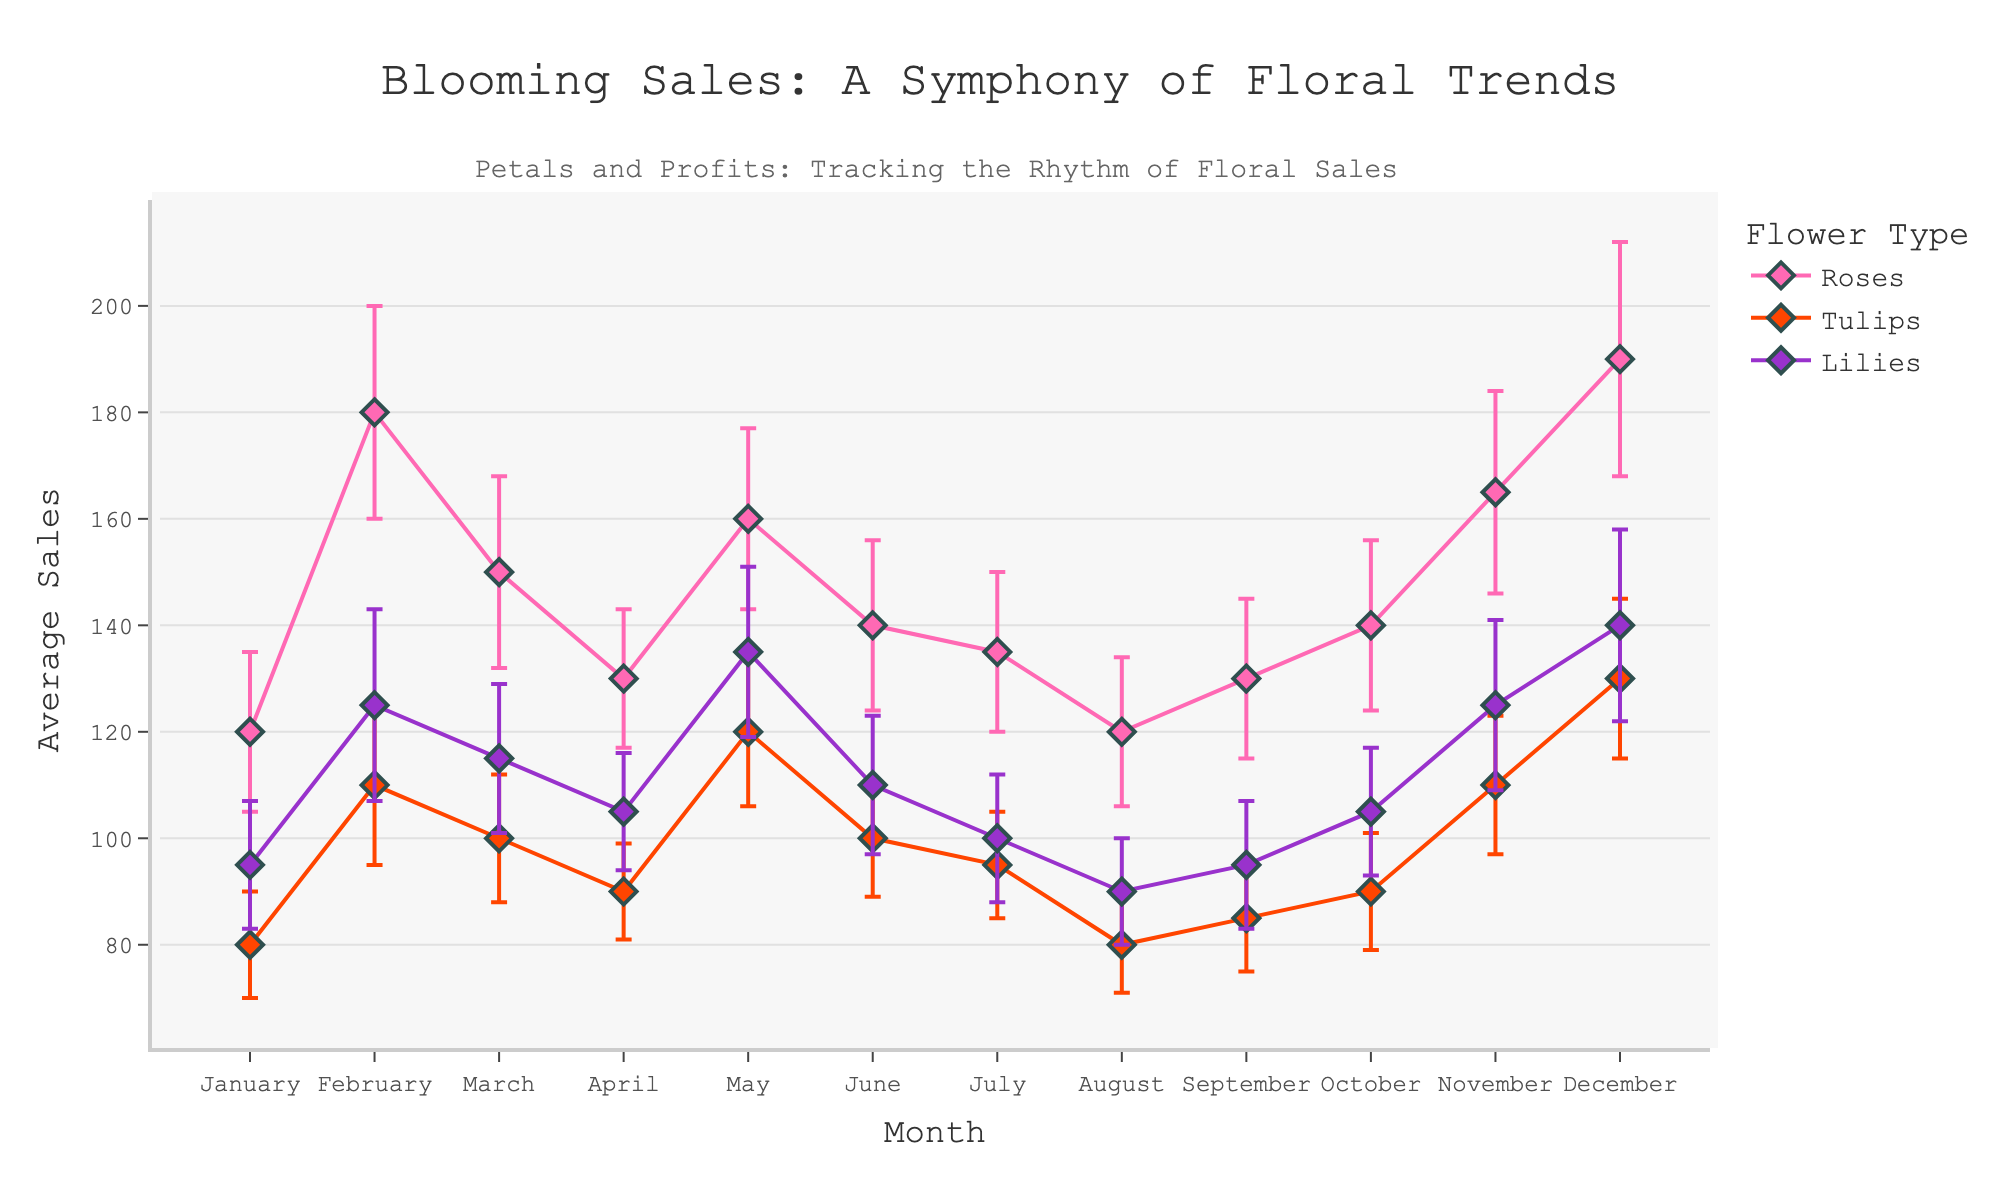What's the title of the plot? The title is displayed at the top of the plot and gives an overview of the subject of the figure. Here it is concise and prominently placed.
Answer: Blooming Sales: A Symphony of Floral Trends What are the average sales of roses in May? Locate May on the x-axis and find the point representing roses. The y-axis value for this point indicates the average sales in May.
Answer: 160 Which flower type had the highest average sales in December? Look for December on the x-axis and compare the y-axis values of the points representing each flower type. The highest point indicates the flower type with the highest sales.
Answer: Roses How do the error bars for lilies in February compare to those in June? Error bars represent the fluctuations in sales. By comparing the lengths of the error bars for lilies in February and June, we can see which month had higher variability.
Answer: February error bars are longer What's the difference in the average sales between roses and tulips in February? Refer to February on the x-axis and note the y-axis values for roses and tulips. Subtract the average sales of tulips from the average sales of roses to find the difference.
Answer: 70 Which month shows the largest fluctuations in tulip sales? Fluctuations are represented by the lengths of error bars. By visually comparing the error bars for tulips across different months, identify the month with the longest error bars.
Answer: February How do the sales trends of lilies progress from January to December? Follow the trajectory of the lily data points from January to December. Identify any increases, decreases, or stable periods in average sales.
Answer: Largely increasing Which flower type showed a significant increase in sales from January to February? Compare the January and February data points and error bars for each flower type to observe changes. Identify the flower type with the largest increase.
Answer: Roses In which month did tulips have their lowest average sales? Finding the lowest point for tulips along their trend line and mapping it to the x-axis will reveal the month with the lowest average sales.
Answer: August Comparing the three flower types, which one shows the least variability throughout the year? Assess the length of the error bars for each flower type across all months and determine which flower type has the smallest and most consistent error bars.
Answer: Tulips 